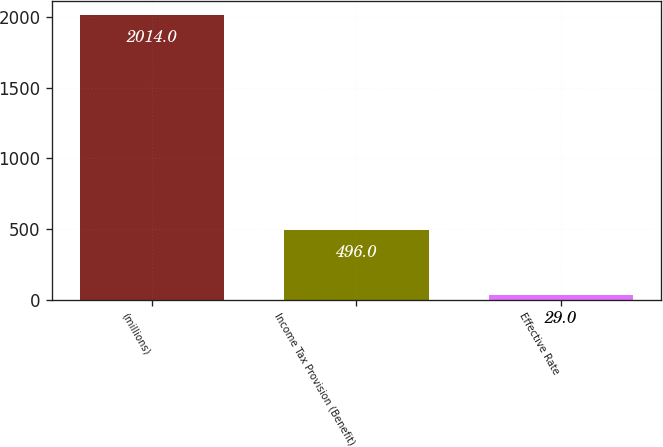<chart> <loc_0><loc_0><loc_500><loc_500><bar_chart><fcel>(millions)<fcel>Income Tax Provision (Benefit)<fcel>Effective Rate<nl><fcel>2014<fcel>496<fcel>29<nl></chart> 